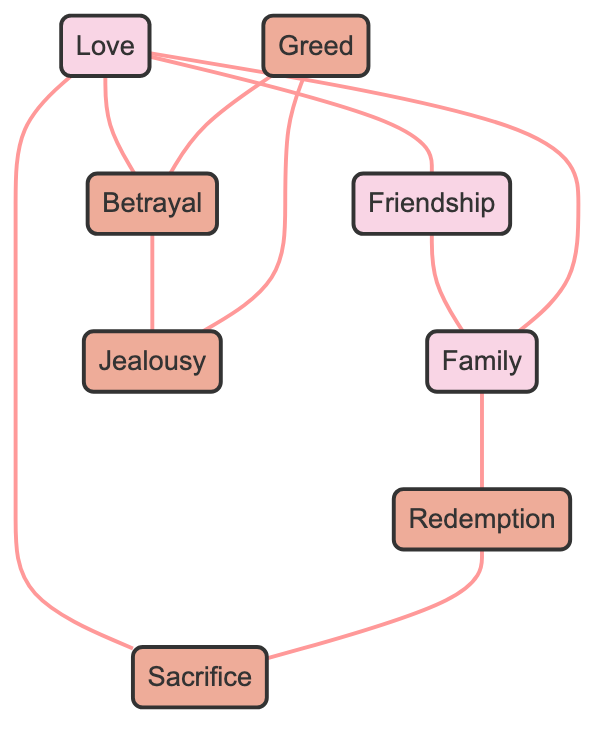What are the primary themes represented in the nodes? The nodes representing primary themes are Love, Family, Friendship. These are identified by their labels in the diagram without any indication of being subplots.
Answer: Love, Family, Friendship How many nodes are in the diagram? By counting the entries in the "nodes" section, we find there are a total of 8 distinct themes and subplots present in the diagram.
Answer: 8 What is the relationship between Love and Betrayal? The edge connecting the nodes with labels 'Love' and 'Betrayal' indicates a direct relationship, as they are connected by a line in the diagram.
Answer: Connected Which subplot is associated with Jealousy? The edge indicates that Jealousy is directly influenced by Betrayal, which is reflected in the connection between Jealousy and Betrayal in the nodes.
Answer: Betrayal What is the total number of edges in this undirected graph? By counting the entries in the "edges" section, we determine there are 10 connections between the nodes, indicating how the themes and subplots are interrelated.
Answer: 10 Which theme influences Redemption? The edge indicates that the theme of Family influences Redemption, as there is a direct connection between these two nodes in the diagram.
Answer: Family How many subplots are influenced by the theme of Friendship? The diagram shows that Friendship influences Love and Family, with edges connecting to each, indicating two distinct influences.
Answer: 2 What theme is associated with Sacrifice? The edge identifies that Sacrifice is connected with Love and Redemption, highlighting its impact by tracing the connections leading away from it.
Answer: Love, Redemption Which two themes/subplots are connected to Greed? Tracing the edges from Greed, the connected subplots are Betrayal and Jealousy, both showing direct connections in the graph.
Answer: Betrayal, Jealousy 